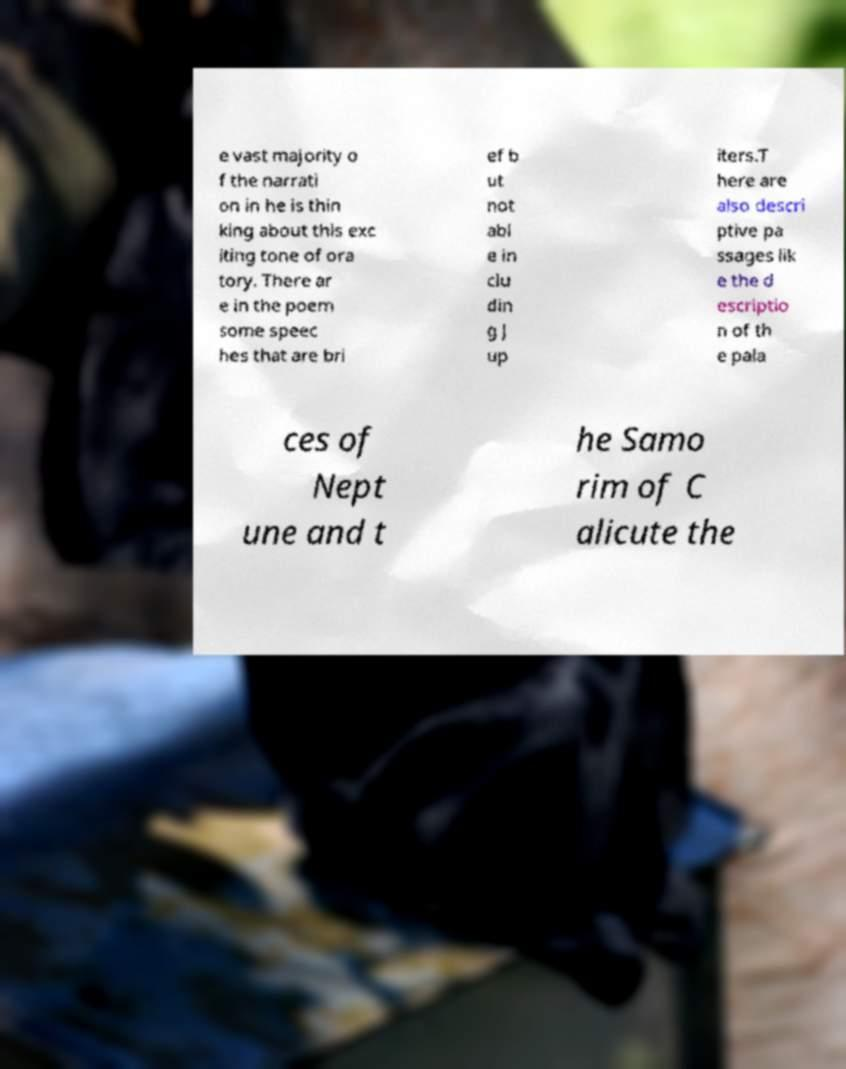Please identify and transcribe the text found in this image. e vast majority o f the narrati on in he is thin king about this exc iting tone of ora tory. There ar e in the poem some speec hes that are bri ef b ut not abl e in clu din g J up iters.T here are also descri ptive pa ssages lik e the d escriptio n of th e pala ces of Nept une and t he Samo rim of C alicute the 